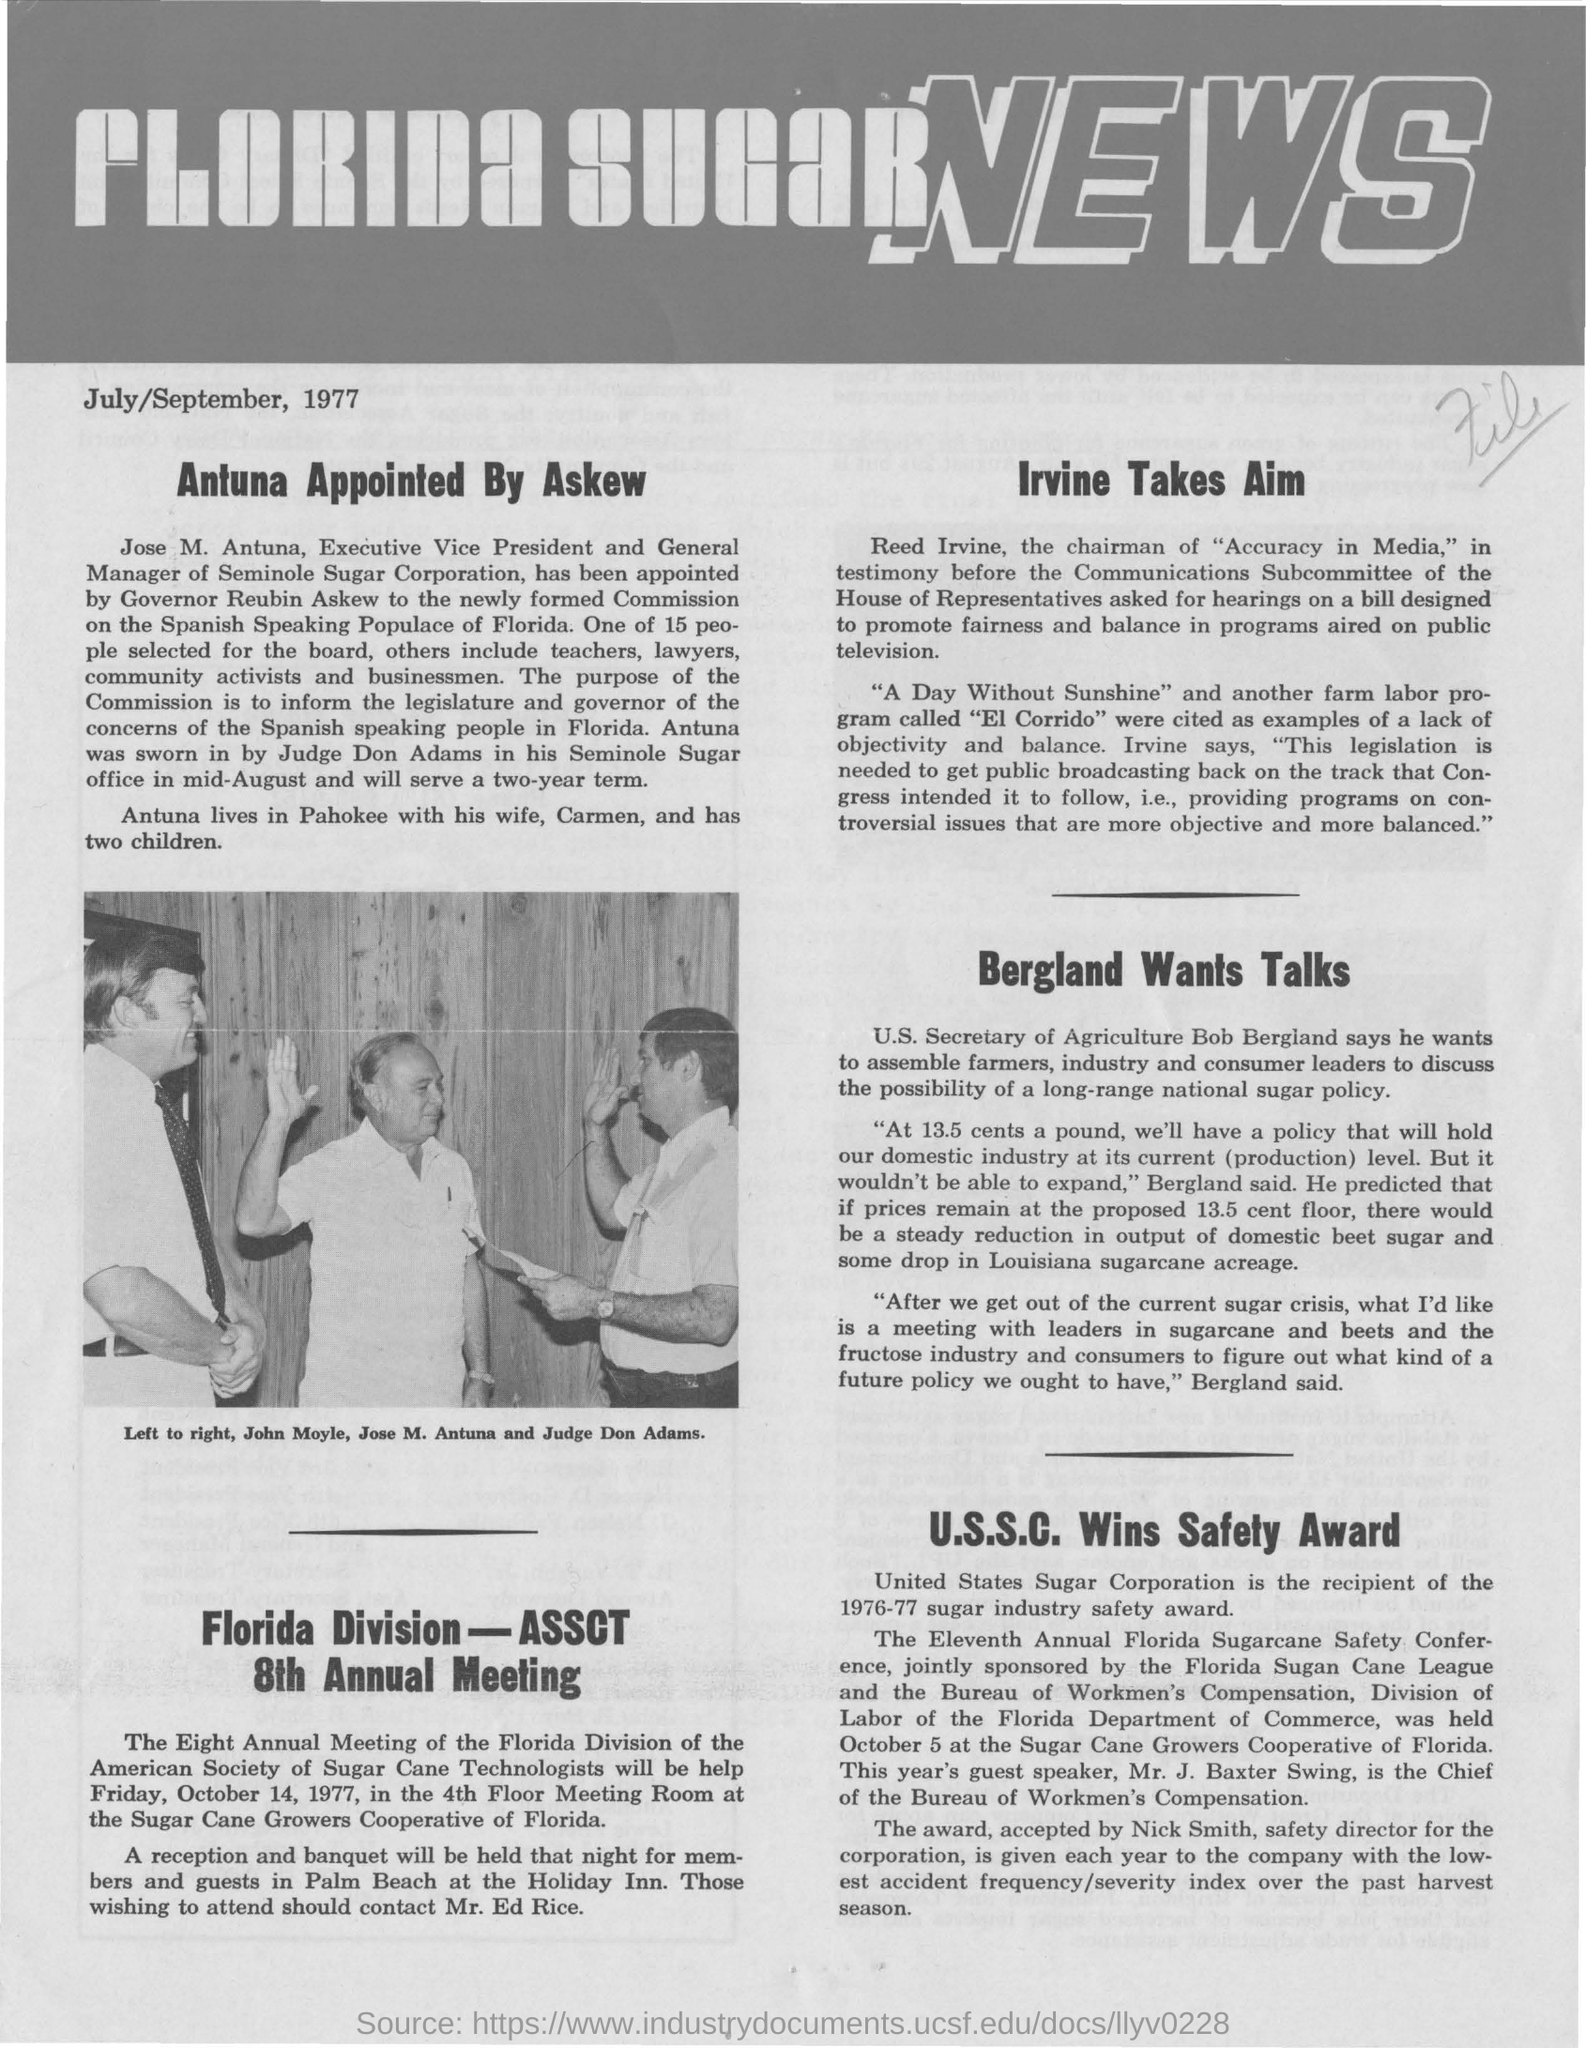What is the heading of the document?
Offer a very short reply. Florida Sugar News. What is the date mentioned?
Provide a succinct answer. July/September, 1977. What is the name of man standing in middle in the picture?
Your answer should be compact. Jose M. Antuna. Who is the Executive Vice President and General Manager of Seminole Sugar Corporation?
Provide a short and direct response. Jose M. Antuna. 